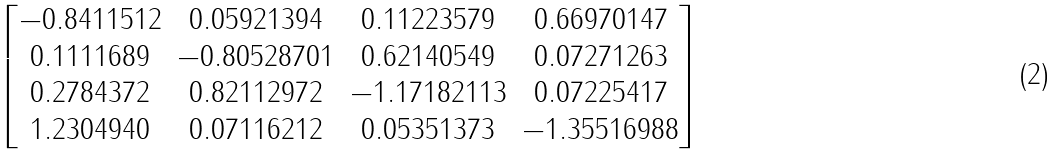<formula> <loc_0><loc_0><loc_500><loc_500>\begin{bmatrix} - 0 . 8 4 1 1 5 1 2 & 0 . 0 5 9 2 1 3 9 4 & 0 . 1 1 2 2 3 5 7 9 & 0 . 6 6 9 7 0 1 4 7 \\ 0 . 1 1 1 1 6 8 9 & - 0 . 8 0 5 2 8 7 0 1 & 0 . 6 2 1 4 0 5 4 9 & 0 . 0 7 2 7 1 2 6 3 \\ 0 . 2 7 8 4 3 7 2 & 0 . 8 2 1 1 2 9 7 2 & - 1 . 1 7 1 8 2 1 1 3 & 0 . 0 7 2 2 5 4 1 7 \\ 1 . 2 3 0 4 9 4 0 & 0 . 0 7 1 1 6 2 1 2 & 0 . 0 5 3 5 1 3 7 3 & - 1 . 3 5 5 1 6 9 8 8 \end{bmatrix}</formula> 